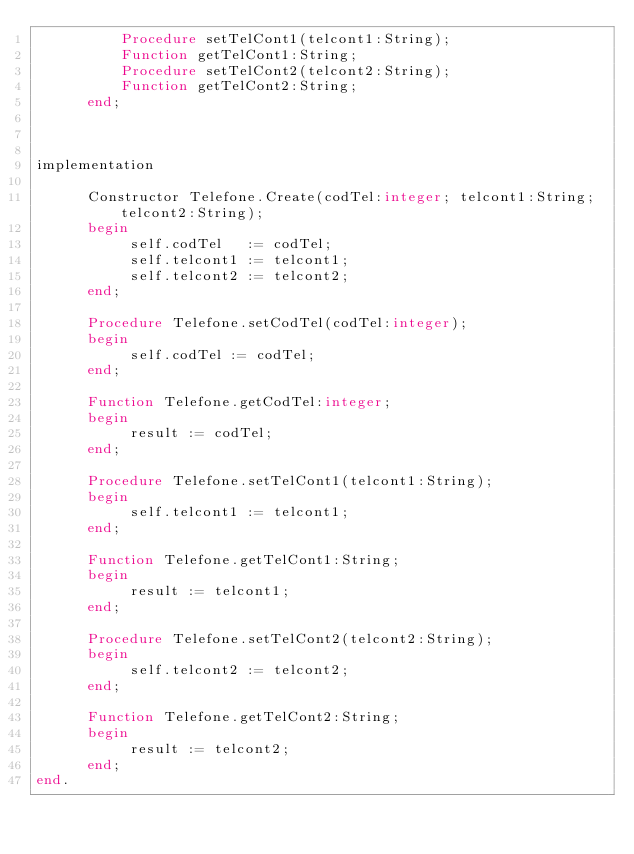<code> <loc_0><loc_0><loc_500><loc_500><_Pascal_>          Procedure setTelCont1(telcont1:String);
          Function getTelCont1:String;
          Procedure setTelCont2(telcont2:String);
          Function getTelCont2:String;
      end;



implementation

      Constructor Telefone.Create(codTel:integer; telcont1:String; telcont2:String);
      begin
           self.codTel   := codTel;
           self.telcont1 := telcont1;
           self.telcont2 := telcont2;
      end;

      Procedure Telefone.setCodTel(codTel:integer);
      begin
           self.codTel := codTel;
      end;

      Function Telefone.getCodTel:integer;
      begin
           result := codTel;
      end;

      Procedure Telefone.setTelCont1(telcont1:String);
      begin
           self.telcont1 := telcont1;
      end;

      Function Telefone.getTelCont1:String;
      begin
           result := telcont1;
      end;

      Procedure Telefone.setTelCont2(telcont2:String);
      begin
           self.telcont2 := telcont2;
      end;

      Function Telefone.getTelCont2:String;
      begin
           result := telcont2;
      end;
end.
</code> 